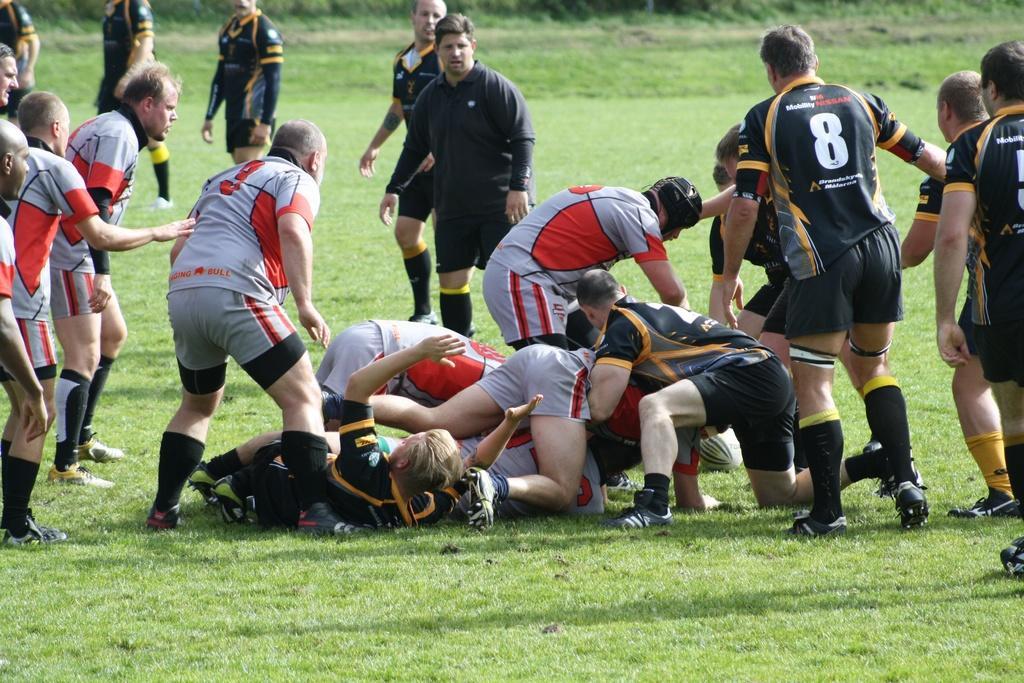Please provide a concise description of this image. This picture is clicked outside. In the center we can see the group of people wearing t-shirts and seems to be standing on the ground, the ground is covered with the green grass and we can see the text and numbers on the t-shirts. In the middle we can see the group of people seems to be lying on one another and we can see a person wearing t-shirt and seems to be crouching on the ground and there is a ball placed on the ground. In the background we can see the group of people wearing t-shirts and we can see the green grass. 